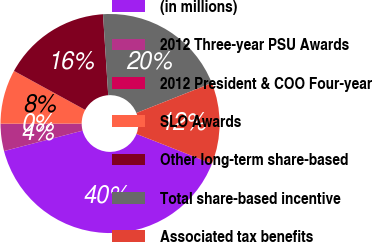<chart> <loc_0><loc_0><loc_500><loc_500><pie_chart><fcel>(in millions)<fcel>2012 Three-year PSU Awards<fcel>2012 President & COO Four-year<fcel>SLO Awards<fcel>Other long-term share-based<fcel>Total share-based incentive<fcel>Associated tax benefits<nl><fcel>39.99%<fcel>4.01%<fcel>0.01%<fcel>8.0%<fcel>16.0%<fcel>20.0%<fcel>12.0%<nl></chart> 